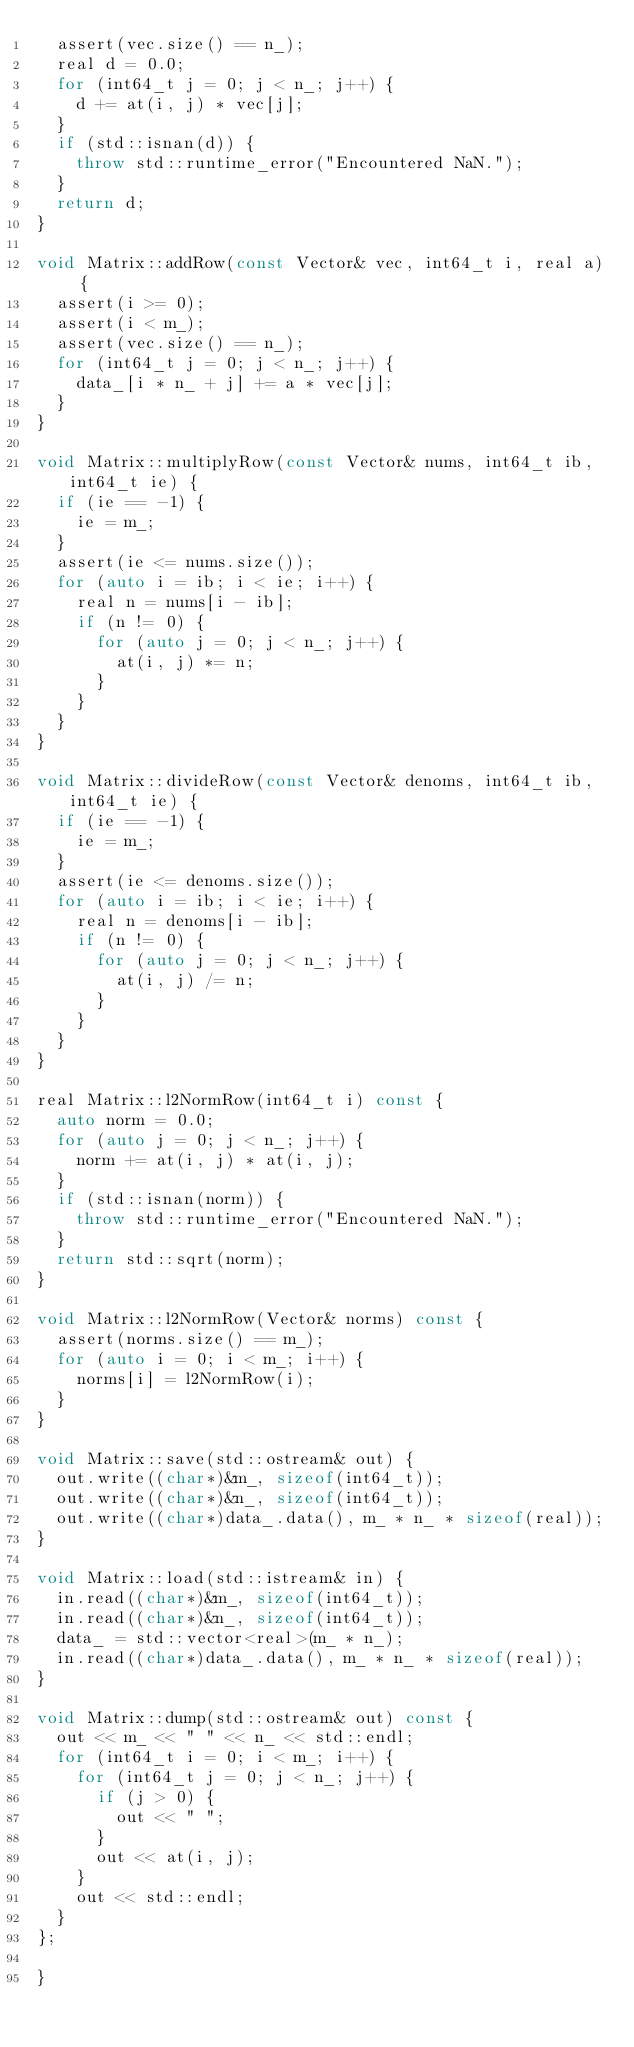<code> <loc_0><loc_0><loc_500><loc_500><_C++_>  assert(vec.size() == n_);
  real d = 0.0;
  for (int64_t j = 0; j < n_; j++) {
    d += at(i, j) * vec[j];
  }
  if (std::isnan(d)) {
    throw std::runtime_error("Encountered NaN.");
  }
  return d;
}

void Matrix::addRow(const Vector& vec, int64_t i, real a) {
  assert(i >= 0);
  assert(i < m_);
  assert(vec.size() == n_);
  for (int64_t j = 0; j < n_; j++) {
    data_[i * n_ + j] += a * vec[j];
  }
}

void Matrix::multiplyRow(const Vector& nums, int64_t ib, int64_t ie) {
  if (ie == -1) {
    ie = m_;
  }
  assert(ie <= nums.size());
  for (auto i = ib; i < ie; i++) {
    real n = nums[i - ib];
    if (n != 0) {
      for (auto j = 0; j < n_; j++) {
        at(i, j) *= n;
      }
    }
  }
}

void Matrix::divideRow(const Vector& denoms, int64_t ib, int64_t ie) {
  if (ie == -1) {
    ie = m_;
  }
  assert(ie <= denoms.size());
  for (auto i = ib; i < ie; i++) {
    real n = denoms[i - ib];
    if (n != 0) {
      for (auto j = 0; j < n_; j++) {
        at(i, j) /= n;
      }
    }
  }
}

real Matrix::l2NormRow(int64_t i) const {
  auto norm = 0.0;
  for (auto j = 0; j < n_; j++) {
    norm += at(i, j) * at(i, j);
  }
  if (std::isnan(norm)) {
    throw std::runtime_error("Encountered NaN.");
  }
  return std::sqrt(norm);
}

void Matrix::l2NormRow(Vector& norms) const {
  assert(norms.size() == m_);
  for (auto i = 0; i < m_; i++) {
    norms[i] = l2NormRow(i);
  }
}

void Matrix::save(std::ostream& out) {
  out.write((char*)&m_, sizeof(int64_t));
  out.write((char*)&n_, sizeof(int64_t));
  out.write((char*)data_.data(), m_ * n_ * sizeof(real));
}

void Matrix::load(std::istream& in) {
  in.read((char*)&m_, sizeof(int64_t));
  in.read((char*)&n_, sizeof(int64_t));
  data_ = std::vector<real>(m_ * n_);
  in.read((char*)data_.data(), m_ * n_ * sizeof(real));
}

void Matrix::dump(std::ostream& out) const {
  out << m_ << " " << n_ << std::endl;
  for (int64_t i = 0; i < m_; i++) {
    for (int64_t j = 0; j < n_; j++) {
      if (j > 0) {
        out << " ";
      }
      out << at(i, j);
    }
    out << std::endl;
  }
};

}
</code> 